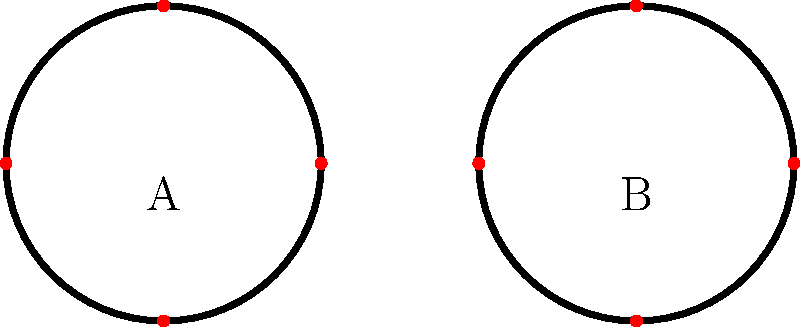In a forensic analysis of ligature patterns, two knots (A and B) were found at a crime scene. If knot A has a crossing number of 3 and knot B has a crossing number of 5, what is the difference in their Jones polynomials' degrees? To solve this problem, we need to understand the relationship between crossing numbers and Jones polynomials in knot theory:

1. The crossing number of a knot is the minimum number of crossings in any diagram of the knot.

2. The Jones polynomial is a knot invariant that can distinguish between many knots.

3. For alternating knots (which are common in real-world scenarios), there's a relationship between the crossing number and the degree of the Jones polynomial:

   The degree of the Jones polynomial = $c - 1$, where $c$ is the crossing number.

4. For knot A:
   Crossing number = 3
   Degree of Jones polynomial = $3 - 1 = 2$

5. For knot B:
   Crossing number = 5
   Degree of Jones polynomial = $5 - 1 = 4$

6. The difference in degrees:
   $4 - 2 = 2$

Therefore, the difference in the degrees of their Jones polynomials is 2.
Answer: 2 